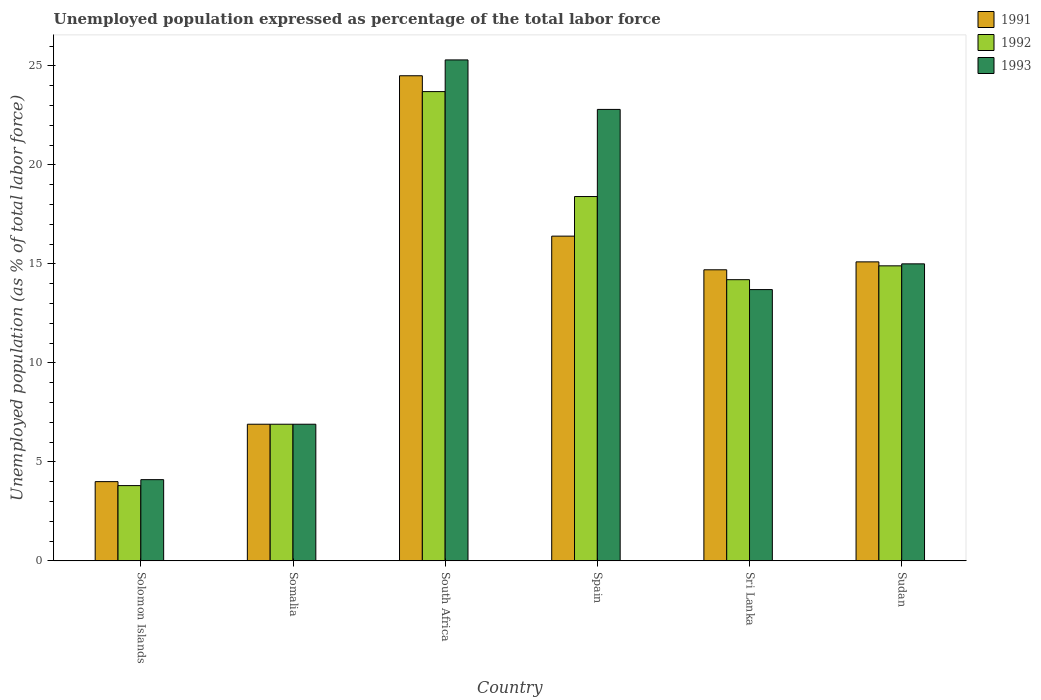How many different coloured bars are there?
Provide a succinct answer. 3. What is the label of the 4th group of bars from the left?
Keep it short and to the point. Spain. In how many cases, is the number of bars for a given country not equal to the number of legend labels?
Your answer should be very brief. 0. What is the unemployment in in 1993 in Solomon Islands?
Offer a very short reply. 4.1. Across all countries, what is the maximum unemployment in in 1992?
Provide a short and direct response. 23.7. Across all countries, what is the minimum unemployment in in 1992?
Provide a succinct answer. 3.8. In which country was the unemployment in in 1993 maximum?
Ensure brevity in your answer.  South Africa. In which country was the unemployment in in 1992 minimum?
Offer a terse response. Solomon Islands. What is the total unemployment in in 1993 in the graph?
Offer a terse response. 87.8. What is the difference between the unemployment in in 1992 in Spain and that in Sudan?
Keep it short and to the point. 3.5. What is the difference between the unemployment in in 1991 in Spain and the unemployment in in 1992 in Somalia?
Offer a very short reply. 9.5. What is the average unemployment in in 1991 per country?
Offer a very short reply. 13.6. What is the difference between the unemployment in of/in 1991 and unemployment in of/in 1993 in Sudan?
Your answer should be very brief. 0.1. What is the ratio of the unemployment in in 1992 in Spain to that in Sudan?
Keep it short and to the point. 1.23. Is the unemployment in in 1992 in Somalia less than that in Sri Lanka?
Give a very brief answer. Yes. What is the difference between the highest and the second highest unemployment in in 1991?
Provide a succinct answer. 8.1. What is the difference between the highest and the lowest unemployment in in 1992?
Offer a very short reply. 19.9. In how many countries, is the unemployment in in 1991 greater than the average unemployment in in 1991 taken over all countries?
Offer a very short reply. 4. What does the 3rd bar from the left in Sri Lanka represents?
Your response must be concise. 1993. What does the 1st bar from the right in Spain represents?
Your response must be concise. 1993. Are all the bars in the graph horizontal?
Ensure brevity in your answer.  No. How many countries are there in the graph?
Your answer should be compact. 6. How many legend labels are there?
Your answer should be compact. 3. How are the legend labels stacked?
Make the answer very short. Vertical. What is the title of the graph?
Make the answer very short. Unemployed population expressed as percentage of the total labor force. What is the label or title of the X-axis?
Keep it short and to the point. Country. What is the label or title of the Y-axis?
Your answer should be very brief. Unemployed population (as % of total labor force). What is the Unemployed population (as % of total labor force) in 1991 in Solomon Islands?
Provide a succinct answer. 4. What is the Unemployed population (as % of total labor force) in 1992 in Solomon Islands?
Provide a succinct answer. 3.8. What is the Unemployed population (as % of total labor force) in 1993 in Solomon Islands?
Provide a succinct answer. 4.1. What is the Unemployed population (as % of total labor force) in 1991 in Somalia?
Give a very brief answer. 6.9. What is the Unemployed population (as % of total labor force) in 1992 in Somalia?
Your answer should be very brief. 6.9. What is the Unemployed population (as % of total labor force) of 1993 in Somalia?
Your answer should be very brief. 6.9. What is the Unemployed population (as % of total labor force) of 1991 in South Africa?
Offer a terse response. 24.5. What is the Unemployed population (as % of total labor force) in 1992 in South Africa?
Your answer should be compact. 23.7. What is the Unemployed population (as % of total labor force) in 1993 in South Africa?
Ensure brevity in your answer.  25.3. What is the Unemployed population (as % of total labor force) in 1991 in Spain?
Your answer should be compact. 16.4. What is the Unemployed population (as % of total labor force) in 1992 in Spain?
Offer a terse response. 18.4. What is the Unemployed population (as % of total labor force) of 1993 in Spain?
Your response must be concise. 22.8. What is the Unemployed population (as % of total labor force) in 1991 in Sri Lanka?
Give a very brief answer. 14.7. What is the Unemployed population (as % of total labor force) in 1992 in Sri Lanka?
Make the answer very short. 14.2. What is the Unemployed population (as % of total labor force) in 1993 in Sri Lanka?
Keep it short and to the point. 13.7. What is the Unemployed population (as % of total labor force) of 1991 in Sudan?
Provide a succinct answer. 15.1. What is the Unemployed population (as % of total labor force) in 1992 in Sudan?
Offer a terse response. 14.9. Across all countries, what is the maximum Unemployed population (as % of total labor force) of 1992?
Provide a succinct answer. 23.7. Across all countries, what is the maximum Unemployed population (as % of total labor force) of 1993?
Provide a succinct answer. 25.3. Across all countries, what is the minimum Unemployed population (as % of total labor force) of 1991?
Your response must be concise. 4. Across all countries, what is the minimum Unemployed population (as % of total labor force) of 1992?
Offer a terse response. 3.8. Across all countries, what is the minimum Unemployed population (as % of total labor force) in 1993?
Provide a short and direct response. 4.1. What is the total Unemployed population (as % of total labor force) in 1991 in the graph?
Your answer should be very brief. 81.6. What is the total Unemployed population (as % of total labor force) in 1992 in the graph?
Keep it short and to the point. 81.9. What is the total Unemployed population (as % of total labor force) of 1993 in the graph?
Your response must be concise. 87.8. What is the difference between the Unemployed population (as % of total labor force) in 1991 in Solomon Islands and that in Somalia?
Offer a terse response. -2.9. What is the difference between the Unemployed population (as % of total labor force) in 1992 in Solomon Islands and that in Somalia?
Your response must be concise. -3.1. What is the difference between the Unemployed population (as % of total labor force) in 1993 in Solomon Islands and that in Somalia?
Offer a terse response. -2.8. What is the difference between the Unemployed population (as % of total labor force) in 1991 in Solomon Islands and that in South Africa?
Make the answer very short. -20.5. What is the difference between the Unemployed population (as % of total labor force) in 1992 in Solomon Islands and that in South Africa?
Your answer should be compact. -19.9. What is the difference between the Unemployed population (as % of total labor force) of 1993 in Solomon Islands and that in South Africa?
Your answer should be compact. -21.2. What is the difference between the Unemployed population (as % of total labor force) of 1991 in Solomon Islands and that in Spain?
Offer a terse response. -12.4. What is the difference between the Unemployed population (as % of total labor force) of 1992 in Solomon Islands and that in Spain?
Keep it short and to the point. -14.6. What is the difference between the Unemployed population (as % of total labor force) in 1993 in Solomon Islands and that in Spain?
Keep it short and to the point. -18.7. What is the difference between the Unemployed population (as % of total labor force) in 1992 in Solomon Islands and that in Sri Lanka?
Your answer should be compact. -10.4. What is the difference between the Unemployed population (as % of total labor force) of 1993 in Solomon Islands and that in Sri Lanka?
Make the answer very short. -9.6. What is the difference between the Unemployed population (as % of total labor force) of 1991 in Solomon Islands and that in Sudan?
Your answer should be very brief. -11.1. What is the difference between the Unemployed population (as % of total labor force) of 1992 in Solomon Islands and that in Sudan?
Offer a terse response. -11.1. What is the difference between the Unemployed population (as % of total labor force) of 1993 in Solomon Islands and that in Sudan?
Your answer should be very brief. -10.9. What is the difference between the Unemployed population (as % of total labor force) in 1991 in Somalia and that in South Africa?
Your answer should be very brief. -17.6. What is the difference between the Unemployed population (as % of total labor force) of 1992 in Somalia and that in South Africa?
Make the answer very short. -16.8. What is the difference between the Unemployed population (as % of total labor force) in 1993 in Somalia and that in South Africa?
Provide a succinct answer. -18.4. What is the difference between the Unemployed population (as % of total labor force) in 1991 in Somalia and that in Spain?
Ensure brevity in your answer.  -9.5. What is the difference between the Unemployed population (as % of total labor force) of 1993 in Somalia and that in Spain?
Provide a succinct answer. -15.9. What is the difference between the Unemployed population (as % of total labor force) in 1993 in Somalia and that in Sri Lanka?
Give a very brief answer. -6.8. What is the difference between the Unemployed population (as % of total labor force) in 1992 in Somalia and that in Sudan?
Offer a terse response. -8. What is the difference between the Unemployed population (as % of total labor force) of 1991 in South Africa and that in Spain?
Keep it short and to the point. 8.1. What is the difference between the Unemployed population (as % of total labor force) of 1992 in South Africa and that in Spain?
Offer a terse response. 5.3. What is the difference between the Unemployed population (as % of total labor force) in 1991 in South Africa and that in Sri Lanka?
Your answer should be very brief. 9.8. What is the difference between the Unemployed population (as % of total labor force) in 1992 in South Africa and that in Sri Lanka?
Ensure brevity in your answer.  9.5. What is the difference between the Unemployed population (as % of total labor force) of 1993 in South Africa and that in Sri Lanka?
Ensure brevity in your answer.  11.6. What is the difference between the Unemployed population (as % of total labor force) in 1991 in South Africa and that in Sudan?
Provide a succinct answer. 9.4. What is the difference between the Unemployed population (as % of total labor force) of 1992 in Spain and that in Sri Lanka?
Provide a short and direct response. 4.2. What is the difference between the Unemployed population (as % of total labor force) of 1993 in Spain and that in Sri Lanka?
Provide a short and direct response. 9.1. What is the difference between the Unemployed population (as % of total labor force) in 1991 in Spain and that in Sudan?
Provide a succinct answer. 1.3. What is the difference between the Unemployed population (as % of total labor force) in 1993 in Spain and that in Sudan?
Your answer should be compact. 7.8. What is the difference between the Unemployed population (as % of total labor force) of 1991 in Sri Lanka and that in Sudan?
Offer a terse response. -0.4. What is the difference between the Unemployed population (as % of total labor force) of 1993 in Sri Lanka and that in Sudan?
Your answer should be very brief. -1.3. What is the difference between the Unemployed population (as % of total labor force) of 1991 in Solomon Islands and the Unemployed population (as % of total labor force) of 1993 in Somalia?
Make the answer very short. -2.9. What is the difference between the Unemployed population (as % of total labor force) in 1992 in Solomon Islands and the Unemployed population (as % of total labor force) in 1993 in Somalia?
Provide a short and direct response. -3.1. What is the difference between the Unemployed population (as % of total labor force) of 1991 in Solomon Islands and the Unemployed population (as % of total labor force) of 1992 in South Africa?
Give a very brief answer. -19.7. What is the difference between the Unemployed population (as % of total labor force) of 1991 in Solomon Islands and the Unemployed population (as % of total labor force) of 1993 in South Africa?
Provide a succinct answer. -21.3. What is the difference between the Unemployed population (as % of total labor force) in 1992 in Solomon Islands and the Unemployed population (as % of total labor force) in 1993 in South Africa?
Give a very brief answer. -21.5. What is the difference between the Unemployed population (as % of total labor force) in 1991 in Solomon Islands and the Unemployed population (as % of total labor force) in 1992 in Spain?
Ensure brevity in your answer.  -14.4. What is the difference between the Unemployed population (as % of total labor force) of 1991 in Solomon Islands and the Unemployed population (as % of total labor force) of 1993 in Spain?
Your answer should be very brief. -18.8. What is the difference between the Unemployed population (as % of total labor force) in 1991 in Solomon Islands and the Unemployed population (as % of total labor force) in 1992 in Sri Lanka?
Make the answer very short. -10.2. What is the difference between the Unemployed population (as % of total labor force) of 1992 in Solomon Islands and the Unemployed population (as % of total labor force) of 1993 in Sri Lanka?
Offer a very short reply. -9.9. What is the difference between the Unemployed population (as % of total labor force) in 1991 in Solomon Islands and the Unemployed population (as % of total labor force) in 1993 in Sudan?
Offer a very short reply. -11. What is the difference between the Unemployed population (as % of total labor force) in 1991 in Somalia and the Unemployed population (as % of total labor force) in 1992 in South Africa?
Offer a terse response. -16.8. What is the difference between the Unemployed population (as % of total labor force) in 1991 in Somalia and the Unemployed population (as % of total labor force) in 1993 in South Africa?
Make the answer very short. -18.4. What is the difference between the Unemployed population (as % of total labor force) in 1992 in Somalia and the Unemployed population (as % of total labor force) in 1993 in South Africa?
Your answer should be very brief. -18.4. What is the difference between the Unemployed population (as % of total labor force) of 1991 in Somalia and the Unemployed population (as % of total labor force) of 1993 in Spain?
Provide a short and direct response. -15.9. What is the difference between the Unemployed population (as % of total labor force) in 1992 in Somalia and the Unemployed population (as % of total labor force) in 1993 in Spain?
Ensure brevity in your answer.  -15.9. What is the difference between the Unemployed population (as % of total labor force) of 1991 in Somalia and the Unemployed population (as % of total labor force) of 1992 in Sri Lanka?
Your answer should be compact. -7.3. What is the difference between the Unemployed population (as % of total labor force) in 1991 in Somalia and the Unemployed population (as % of total labor force) in 1992 in Sudan?
Give a very brief answer. -8. What is the difference between the Unemployed population (as % of total labor force) in 1992 in Somalia and the Unemployed population (as % of total labor force) in 1993 in Sudan?
Provide a short and direct response. -8.1. What is the difference between the Unemployed population (as % of total labor force) of 1991 in South Africa and the Unemployed population (as % of total labor force) of 1992 in Spain?
Your response must be concise. 6.1. What is the difference between the Unemployed population (as % of total labor force) of 1991 in South Africa and the Unemployed population (as % of total labor force) of 1993 in Spain?
Provide a succinct answer. 1.7. What is the difference between the Unemployed population (as % of total labor force) of 1991 in South Africa and the Unemployed population (as % of total labor force) of 1993 in Sri Lanka?
Keep it short and to the point. 10.8. What is the difference between the Unemployed population (as % of total labor force) in 1992 in South Africa and the Unemployed population (as % of total labor force) in 1993 in Sri Lanka?
Give a very brief answer. 10. What is the difference between the Unemployed population (as % of total labor force) in 1991 in South Africa and the Unemployed population (as % of total labor force) in 1992 in Sudan?
Make the answer very short. 9.6. What is the difference between the Unemployed population (as % of total labor force) in 1992 in South Africa and the Unemployed population (as % of total labor force) in 1993 in Sudan?
Your answer should be compact. 8.7. What is the difference between the Unemployed population (as % of total labor force) of 1991 in Spain and the Unemployed population (as % of total labor force) of 1992 in Sri Lanka?
Your answer should be very brief. 2.2. What is the difference between the Unemployed population (as % of total labor force) in 1991 in Spain and the Unemployed population (as % of total labor force) in 1993 in Sri Lanka?
Make the answer very short. 2.7. What is the difference between the Unemployed population (as % of total labor force) in 1992 in Spain and the Unemployed population (as % of total labor force) in 1993 in Sri Lanka?
Make the answer very short. 4.7. What is the difference between the Unemployed population (as % of total labor force) of 1991 in Spain and the Unemployed population (as % of total labor force) of 1992 in Sudan?
Your answer should be very brief. 1.5. What is the difference between the Unemployed population (as % of total labor force) of 1991 in Spain and the Unemployed population (as % of total labor force) of 1993 in Sudan?
Give a very brief answer. 1.4. What is the difference between the Unemployed population (as % of total labor force) in 1992 in Sri Lanka and the Unemployed population (as % of total labor force) in 1993 in Sudan?
Provide a short and direct response. -0.8. What is the average Unemployed population (as % of total labor force) of 1991 per country?
Your answer should be compact. 13.6. What is the average Unemployed population (as % of total labor force) in 1992 per country?
Your answer should be very brief. 13.65. What is the average Unemployed population (as % of total labor force) of 1993 per country?
Provide a short and direct response. 14.63. What is the difference between the Unemployed population (as % of total labor force) in 1991 and Unemployed population (as % of total labor force) in 1993 in Solomon Islands?
Make the answer very short. -0.1. What is the difference between the Unemployed population (as % of total labor force) in 1992 and Unemployed population (as % of total labor force) in 1993 in Solomon Islands?
Your response must be concise. -0.3. What is the difference between the Unemployed population (as % of total labor force) of 1991 and Unemployed population (as % of total labor force) of 1992 in South Africa?
Your answer should be compact. 0.8. What is the difference between the Unemployed population (as % of total labor force) of 1991 and Unemployed population (as % of total labor force) of 1993 in South Africa?
Keep it short and to the point. -0.8. What is the difference between the Unemployed population (as % of total labor force) in 1992 and Unemployed population (as % of total labor force) in 1993 in South Africa?
Keep it short and to the point. -1.6. What is the difference between the Unemployed population (as % of total labor force) of 1991 and Unemployed population (as % of total labor force) of 1992 in Spain?
Make the answer very short. -2. What is the difference between the Unemployed population (as % of total labor force) of 1991 and Unemployed population (as % of total labor force) of 1993 in Spain?
Ensure brevity in your answer.  -6.4. What is the difference between the Unemployed population (as % of total labor force) of 1992 and Unemployed population (as % of total labor force) of 1993 in Spain?
Keep it short and to the point. -4.4. What is the difference between the Unemployed population (as % of total labor force) of 1991 and Unemployed population (as % of total labor force) of 1992 in Sri Lanka?
Ensure brevity in your answer.  0.5. What is the difference between the Unemployed population (as % of total labor force) of 1991 and Unemployed population (as % of total labor force) of 1993 in Sri Lanka?
Make the answer very short. 1. What is the difference between the Unemployed population (as % of total labor force) of 1992 and Unemployed population (as % of total labor force) of 1993 in Sri Lanka?
Your response must be concise. 0.5. What is the difference between the Unemployed population (as % of total labor force) in 1991 and Unemployed population (as % of total labor force) in 1992 in Sudan?
Give a very brief answer. 0.2. What is the ratio of the Unemployed population (as % of total labor force) of 1991 in Solomon Islands to that in Somalia?
Your answer should be compact. 0.58. What is the ratio of the Unemployed population (as % of total labor force) of 1992 in Solomon Islands to that in Somalia?
Offer a terse response. 0.55. What is the ratio of the Unemployed population (as % of total labor force) of 1993 in Solomon Islands to that in Somalia?
Your answer should be very brief. 0.59. What is the ratio of the Unemployed population (as % of total labor force) of 1991 in Solomon Islands to that in South Africa?
Make the answer very short. 0.16. What is the ratio of the Unemployed population (as % of total labor force) of 1992 in Solomon Islands to that in South Africa?
Provide a succinct answer. 0.16. What is the ratio of the Unemployed population (as % of total labor force) of 1993 in Solomon Islands to that in South Africa?
Your answer should be compact. 0.16. What is the ratio of the Unemployed population (as % of total labor force) in 1991 in Solomon Islands to that in Spain?
Give a very brief answer. 0.24. What is the ratio of the Unemployed population (as % of total labor force) of 1992 in Solomon Islands to that in Spain?
Your answer should be compact. 0.21. What is the ratio of the Unemployed population (as % of total labor force) of 1993 in Solomon Islands to that in Spain?
Ensure brevity in your answer.  0.18. What is the ratio of the Unemployed population (as % of total labor force) of 1991 in Solomon Islands to that in Sri Lanka?
Provide a succinct answer. 0.27. What is the ratio of the Unemployed population (as % of total labor force) of 1992 in Solomon Islands to that in Sri Lanka?
Your answer should be compact. 0.27. What is the ratio of the Unemployed population (as % of total labor force) in 1993 in Solomon Islands to that in Sri Lanka?
Your response must be concise. 0.3. What is the ratio of the Unemployed population (as % of total labor force) of 1991 in Solomon Islands to that in Sudan?
Your answer should be very brief. 0.26. What is the ratio of the Unemployed population (as % of total labor force) of 1992 in Solomon Islands to that in Sudan?
Your answer should be compact. 0.26. What is the ratio of the Unemployed population (as % of total labor force) in 1993 in Solomon Islands to that in Sudan?
Provide a succinct answer. 0.27. What is the ratio of the Unemployed population (as % of total labor force) in 1991 in Somalia to that in South Africa?
Offer a terse response. 0.28. What is the ratio of the Unemployed population (as % of total labor force) of 1992 in Somalia to that in South Africa?
Your answer should be compact. 0.29. What is the ratio of the Unemployed population (as % of total labor force) in 1993 in Somalia to that in South Africa?
Give a very brief answer. 0.27. What is the ratio of the Unemployed population (as % of total labor force) of 1991 in Somalia to that in Spain?
Make the answer very short. 0.42. What is the ratio of the Unemployed population (as % of total labor force) in 1993 in Somalia to that in Spain?
Your answer should be very brief. 0.3. What is the ratio of the Unemployed population (as % of total labor force) of 1991 in Somalia to that in Sri Lanka?
Keep it short and to the point. 0.47. What is the ratio of the Unemployed population (as % of total labor force) of 1992 in Somalia to that in Sri Lanka?
Offer a very short reply. 0.49. What is the ratio of the Unemployed population (as % of total labor force) in 1993 in Somalia to that in Sri Lanka?
Keep it short and to the point. 0.5. What is the ratio of the Unemployed population (as % of total labor force) of 1991 in Somalia to that in Sudan?
Your answer should be very brief. 0.46. What is the ratio of the Unemployed population (as % of total labor force) of 1992 in Somalia to that in Sudan?
Give a very brief answer. 0.46. What is the ratio of the Unemployed population (as % of total labor force) of 1993 in Somalia to that in Sudan?
Offer a very short reply. 0.46. What is the ratio of the Unemployed population (as % of total labor force) in 1991 in South Africa to that in Spain?
Your response must be concise. 1.49. What is the ratio of the Unemployed population (as % of total labor force) in 1992 in South Africa to that in Spain?
Your answer should be compact. 1.29. What is the ratio of the Unemployed population (as % of total labor force) of 1993 in South Africa to that in Spain?
Ensure brevity in your answer.  1.11. What is the ratio of the Unemployed population (as % of total labor force) in 1992 in South Africa to that in Sri Lanka?
Provide a succinct answer. 1.67. What is the ratio of the Unemployed population (as % of total labor force) of 1993 in South Africa to that in Sri Lanka?
Give a very brief answer. 1.85. What is the ratio of the Unemployed population (as % of total labor force) in 1991 in South Africa to that in Sudan?
Your answer should be compact. 1.62. What is the ratio of the Unemployed population (as % of total labor force) in 1992 in South Africa to that in Sudan?
Provide a short and direct response. 1.59. What is the ratio of the Unemployed population (as % of total labor force) in 1993 in South Africa to that in Sudan?
Ensure brevity in your answer.  1.69. What is the ratio of the Unemployed population (as % of total labor force) in 1991 in Spain to that in Sri Lanka?
Ensure brevity in your answer.  1.12. What is the ratio of the Unemployed population (as % of total labor force) of 1992 in Spain to that in Sri Lanka?
Your response must be concise. 1.3. What is the ratio of the Unemployed population (as % of total labor force) of 1993 in Spain to that in Sri Lanka?
Ensure brevity in your answer.  1.66. What is the ratio of the Unemployed population (as % of total labor force) in 1991 in Spain to that in Sudan?
Ensure brevity in your answer.  1.09. What is the ratio of the Unemployed population (as % of total labor force) of 1992 in Spain to that in Sudan?
Provide a succinct answer. 1.23. What is the ratio of the Unemployed population (as % of total labor force) of 1993 in Spain to that in Sudan?
Give a very brief answer. 1.52. What is the ratio of the Unemployed population (as % of total labor force) in 1991 in Sri Lanka to that in Sudan?
Your answer should be very brief. 0.97. What is the ratio of the Unemployed population (as % of total labor force) of 1992 in Sri Lanka to that in Sudan?
Keep it short and to the point. 0.95. What is the ratio of the Unemployed population (as % of total labor force) in 1993 in Sri Lanka to that in Sudan?
Provide a succinct answer. 0.91. What is the difference between the highest and the second highest Unemployed population (as % of total labor force) of 1991?
Your response must be concise. 8.1. What is the difference between the highest and the second highest Unemployed population (as % of total labor force) of 1992?
Ensure brevity in your answer.  5.3. What is the difference between the highest and the second highest Unemployed population (as % of total labor force) of 1993?
Offer a very short reply. 2.5. What is the difference between the highest and the lowest Unemployed population (as % of total labor force) of 1991?
Give a very brief answer. 20.5. What is the difference between the highest and the lowest Unemployed population (as % of total labor force) of 1992?
Make the answer very short. 19.9. What is the difference between the highest and the lowest Unemployed population (as % of total labor force) in 1993?
Your answer should be compact. 21.2. 